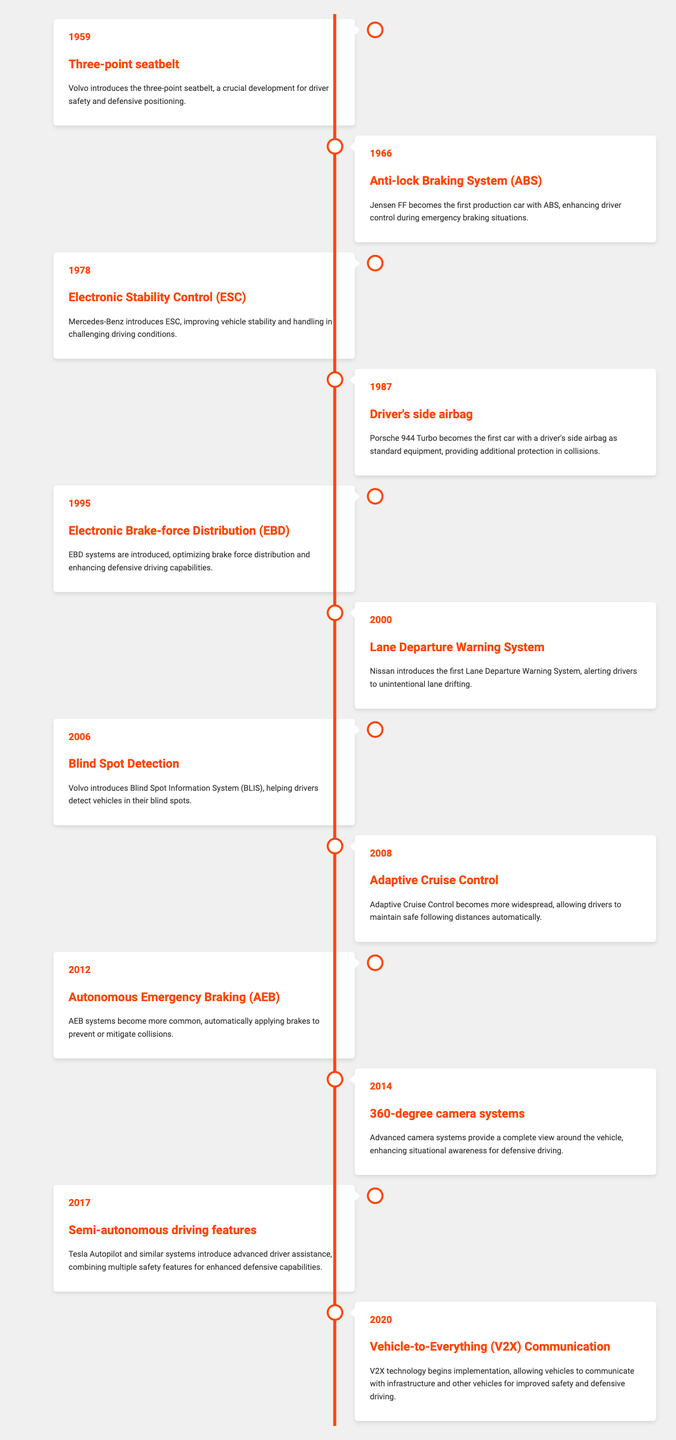What year was the three-point seatbelt introduced? The table lists the first innovation as the three-point seatbelt in the year 1959.
Answer: 1959 Which innovation followed the introduction of the three-point seatbelt? According to the table, after 1959, the next innovation listed is the Anti-lock Braking System (ABS) introduced in 1966.
Answer: Anti-lock Braking System (ABS) How many innovations were introduced between 2000 and 2014? The innovations during that period are as follows: Lane Departure Warning System (2000), Blind Spot Detection (2006), Adaptive Cruise Control (2008), Autonomous Emergency Braking (2012), and 360-degree camera systems (2014). Counting these gives five innovations.
Answer: 5 Was the driver's side airbag introduced before or after the Electronic Stability Control? The Electronic Stability Control was introduced in 1978, while the driver's side airbag was introduced later in 1987, indicating that the airbag was introduced after the stability control system.
Answer: After In which year did the earliest two safety innovations occur, and what were they? The first two innovations are the three-point seatbelt in 1959 and the Anti-lock Braking System (ABS) in 1966. Both innovations fall within the chronological order listed in the table.
Answer: 1959 (Three-point seatbelt) and 1966 (Anti-lock Braking System) How does the introduction of Electronic Brake-force Distribution (EBD) enhance defensive driving? The description states that EBD optimizes brake force distribution, enhancing defensive driving capabilities, which means it improves how the vehicle handles brakes under different conditions for safety.
Answer: It optimizes brake force distribution List the innovations introduced after 2012. The innovations after 2012 in chronological order are: 360-degree camera systems (2014), Semi-autonomous driving features (2017), and Vehicle-to-Everything (V2X) Communication (2020).
Answer: 360-degree camera systems (2014), Semi-autonomous driving features (2017), Vehicle-to-Everything (V2X) Communication (2020) If we consider the period from 1959 to 2020, how many years are there between the introduction of the three-point seatbelt and the Vehicle-to-Everything (V2X) Communication? Calculating the number of years between 1959 and 2020 gives 2020 - 1959 = 61 years.
Answer: 61 years Which innovation was the first to utilize communication technology for enhancing driver safety? The Vehicle-to-Everything (V2X) Communication introduced in 2020 signifies the first use of communication technology aimed at enhancing driver safety according to the table.
Answer: Vehicle-to-Everything (V2X) Communication 